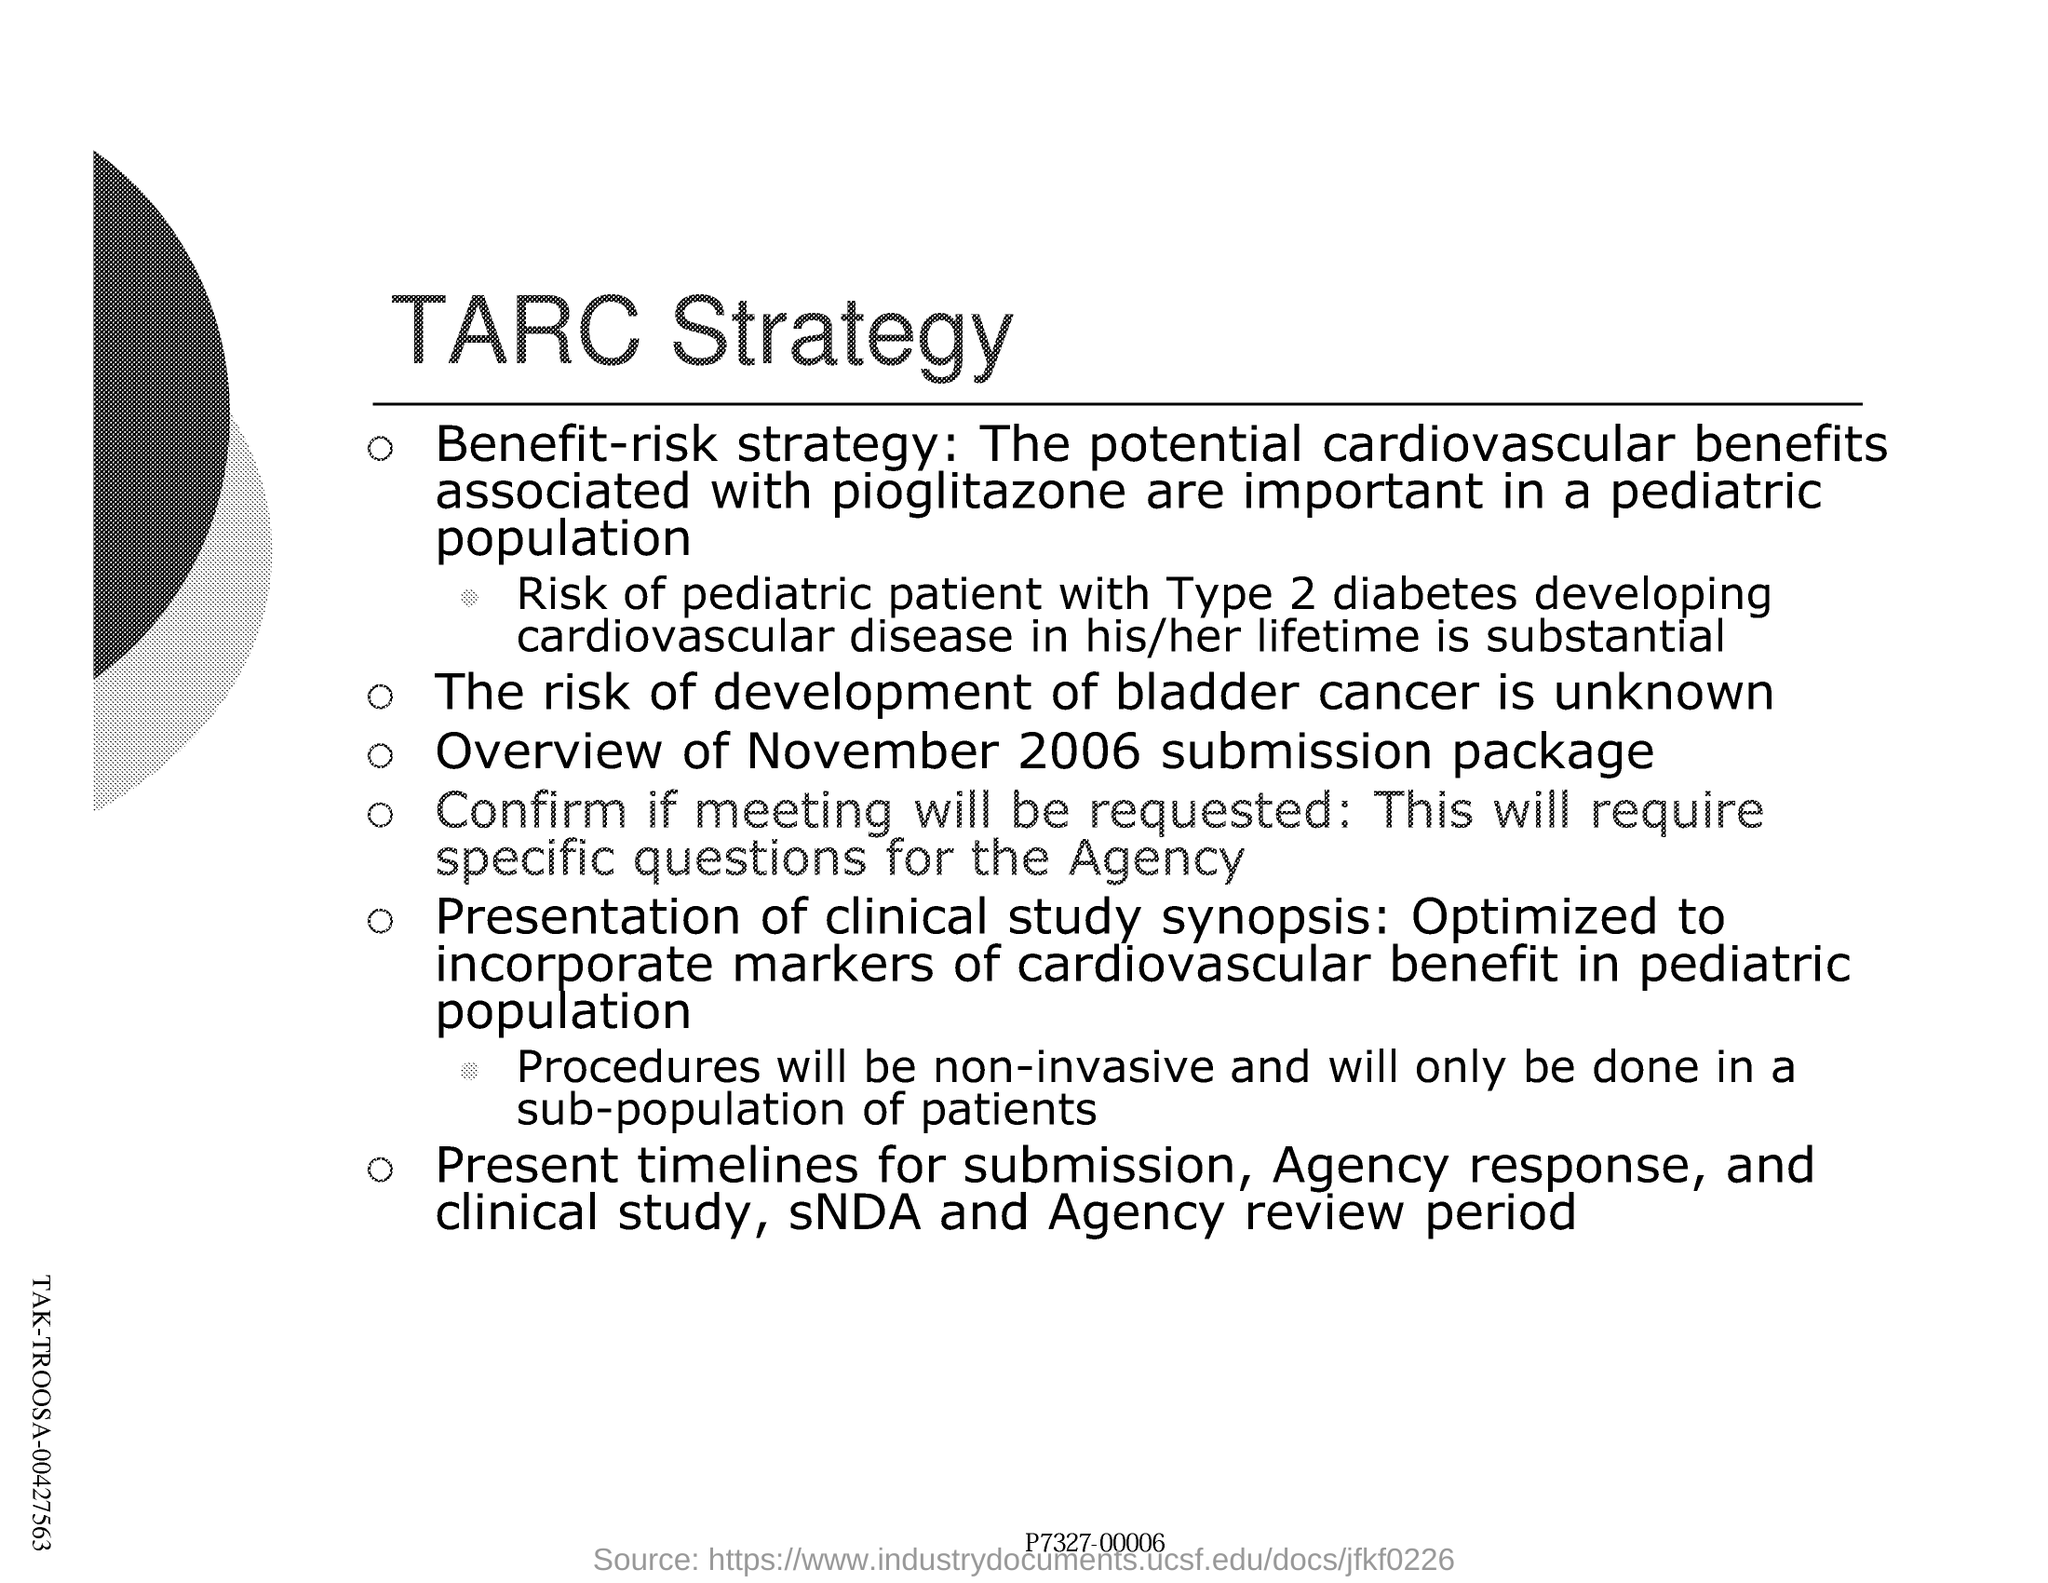What is the title of this document?
Keep it short and to the point. TARC Strategy. 